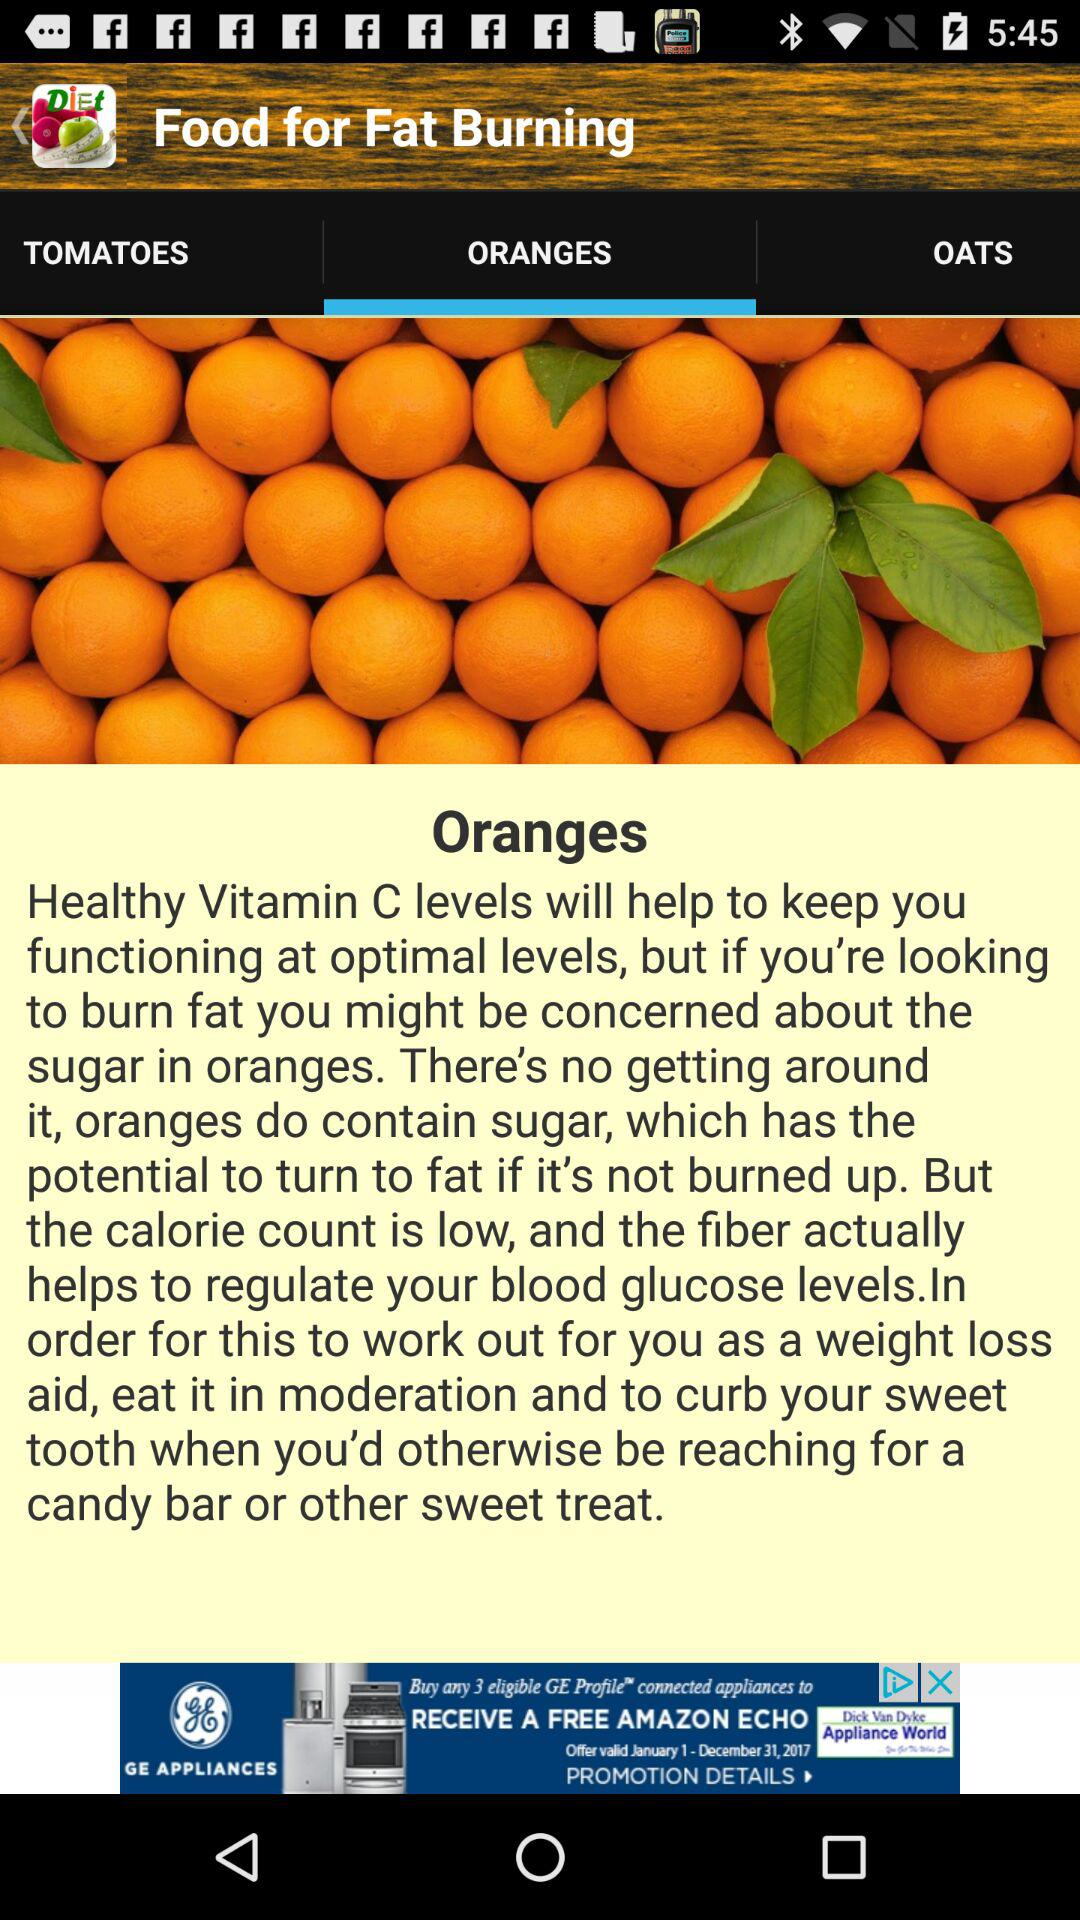Which tab is selected? The selected tab is "ORANGES". 